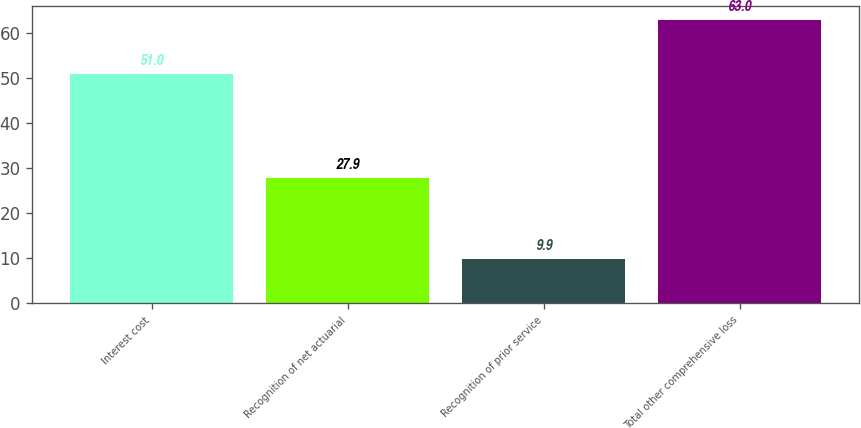Convert chart. <chart><loc_0><loc_0><loc_500><loc_500><bar_chart><fcel>Interest cost<fcel>Recognition of net actuarial<fcel>Recognition of prior service<fcel>Total other comprehensive loss<nl><fcel>51<fcel>27.9<fcel>9.9<fcel>63<nl></chart> 